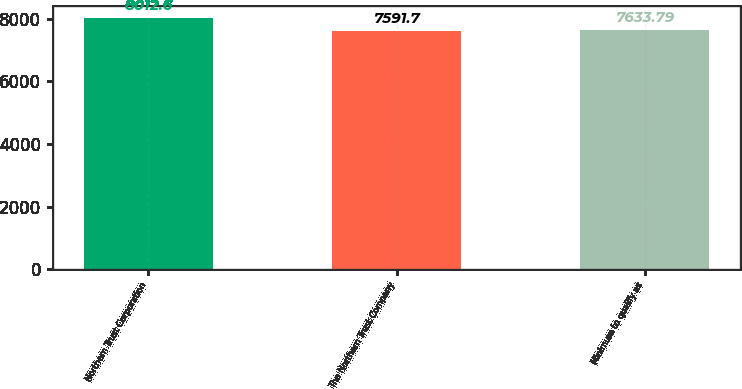Convert chart. <chart><loc_0><loc_0><loc_500><loc_500><bar_chart><fcel>Northern Trust Corporation<fcel>The Northern Trust Company<fcel>Minimum to qualify as<nl><fcel>8012.6<fcel>7591.7<fcel>7633.79<nl></chart> 